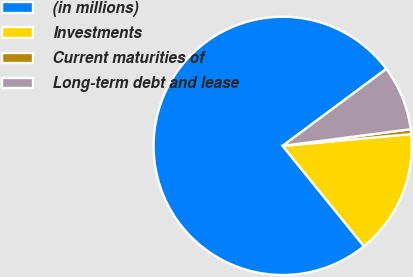Convert chart to OTSL. <chart><loc_0><loc_0><loc_500><loc_500><pie_chart><fcel>(in millions)<fcel>Investments<fcel>Current maturities of<fcel>Long-term debt and lease<nl><fcel>75.67%<fcel>15.62%<fcel>0.6%<fcel>8.11%<nl></chart> 